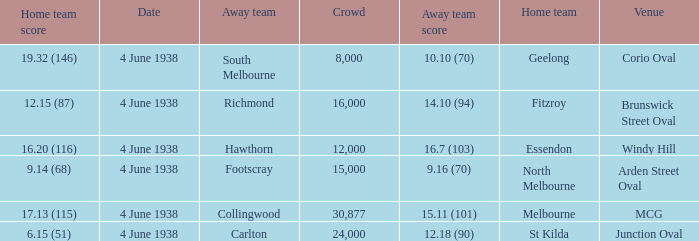What was the score for Geelong? 10.10 (70). 